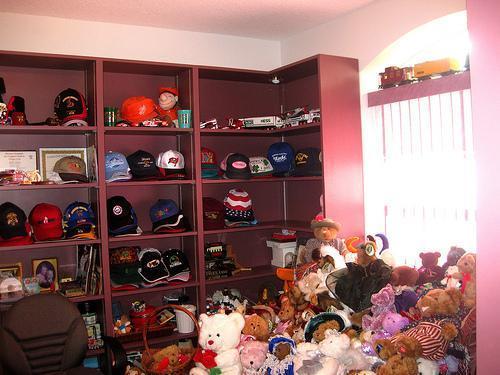How many windows are there?
Give a very brief answer. 1. How many yellow hats are there?
Give a very brief answer. 0. 